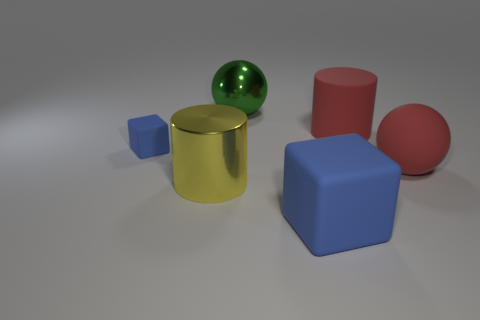Do the tiny cube and the big rubber cube have the same color?
Provide a succinct answer. Yes. What number of other objects are there of the same material as the large blue object?
Offer a terse response. 3. Are there an equal number of blue rubber cubes on the right side of the large yellow object and green blocks?
Your answer should be compact. No. There is a metallic object on the left side of the green metallic sphere; is it the same size as the red matte cylinder?
Offer a terse response. Yes. There is a large red cylinder; how many things are on the right side of it?
Make the answer very short. 1. What is the big object that is both behind the big yellow thing and to the left of the large matte cylinder made of?
Offer a terse response. Metal. What number of small things are blue metal cubes or matte things?
Your answer should be compact. 1. How big is the yellow shiny thing?
Make the answer very short. Large. The large yellow metal thing has what shape?
Make the answer very short. Cylinder. Is the number of green metal balls behind the large block less than the number of blue matte cubes?
Give a very brief answer. Yes. 